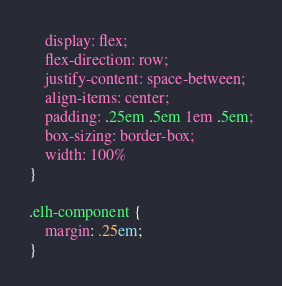Convert code to text. <code><loc_0><loc_0><loc_500><loc_500><_CSS_>    display: flex;
    flex-direction: row;
    justify-content: space-between;
    align-items: center;
    padding: .25em .5em 1em .5em;
    box-sizing: border-box;
    width: 100%
}

.elh-component {
    margin: .25em;
}
</code> 